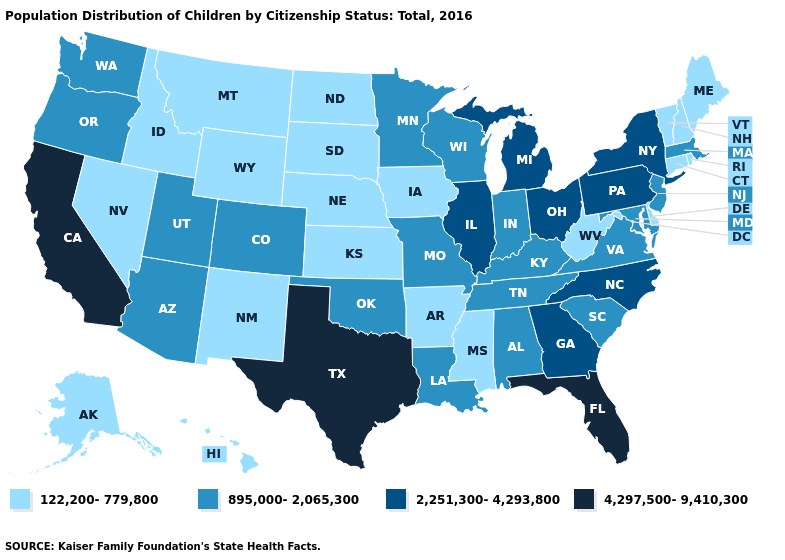Does the map have missing data?
Quick response, please. No. Among the states that border Pennsylvania , does Maryland have the highest value?
Quick response, please. No. What is the value of Kansas?
Quick response, please. 122,200-779,800. Name the states that have a value in the range 895,000-2,065,300?
Concise answer only. Alabama, Arizona, Colorado, Indiana, Kentucky, Louisiana, Maryland, Massachusetts, Minnesota, Missouri, New Jersey, Oklahoma, Oregon, South Carolina, Tennessee, Utah, Virginia, Washington, Wisconsin. Does the map have missing data?
Answer briefly. No. Among the states that border Minnesota , does South Dakota have the lowest value?
Short answer required. Yes. Which states hav the highest value in the South?
Keep it brief. Florida, Texas. Which states have the lowest value in the USA?
Short answer required. Alaska, Arkansas, Connecticut, Delaware, Hawaii, Idaho, Iowa, Kansas, Maine, Mississippi, Montana, Nebraska, Nevada, New Hampshire, New Mexico, North Dakota, Rhode Island, South Dakota, Vermont, West Virginia, Wyoming. Name the states that have a value in the range 2,251,300-4,293,800?
Short answer required. Georgia, Illinois, Michigan, New York, North Carolina, Ohio, Pennsylvania. What is the value of South Carolina?
Answer briefly. 895,000-2,065,300. Does New York have the highest value in the USA?
Be succinct. No. What is the value of Utah?
Write a very short answer. 895,000-2,065,300. What is the value of Ohio?
Quick response, please. 2,251,300-4,293,800. Does the first symbol in the legend represent the smallest category?
Answer briefly. Yes. Does Minnesota have the lowest value in the USA?
Be succinct. No. 